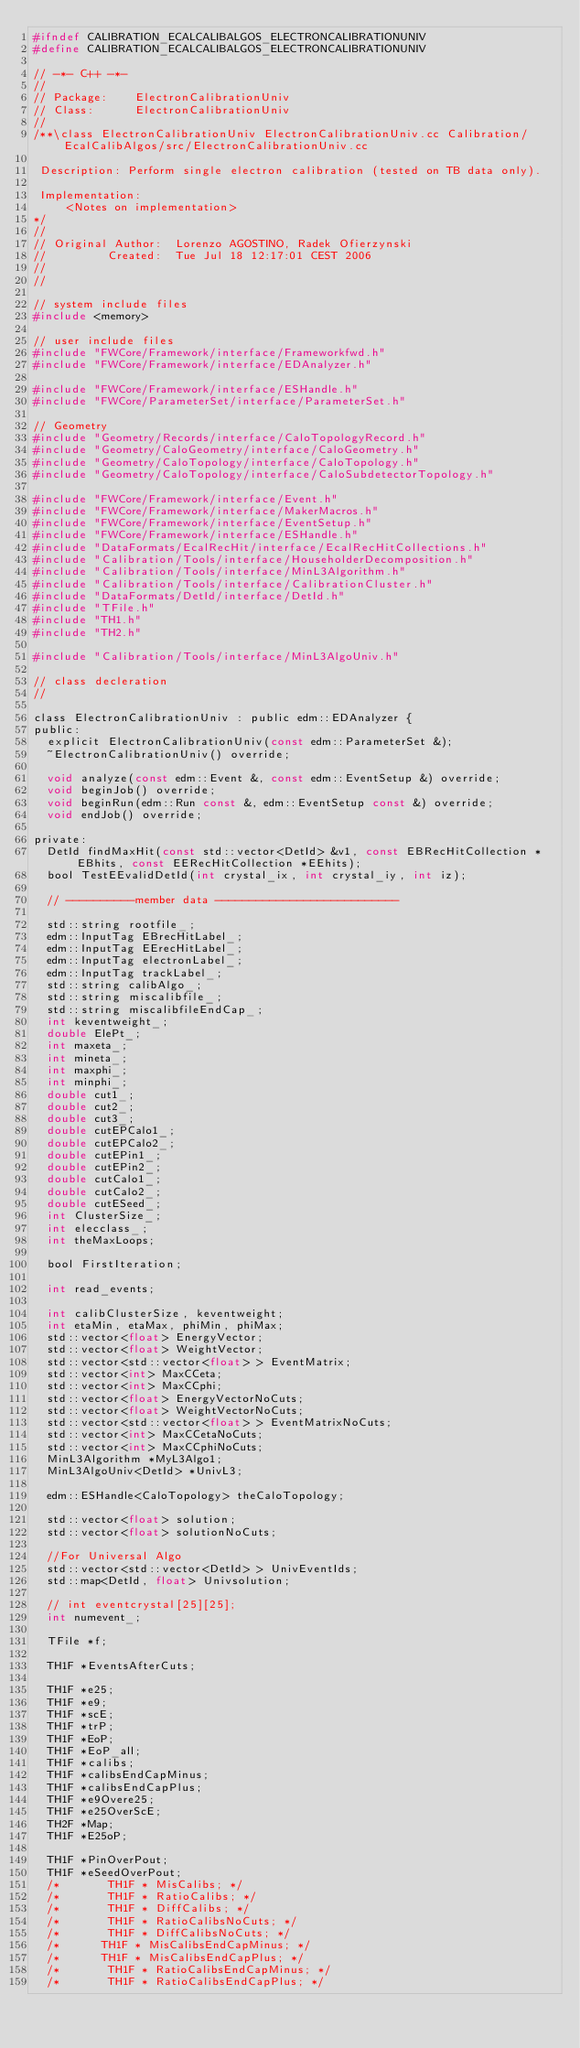Convert code to text. <code><loc_0><loc_0><loc_500><loc_500><_C_>#ifndef CALIBRATION_ECALCALIBALGOS_ELECTRONCALIBRATIONUNIV
#define CALIBRATION_ECALCALIBALGOS_ELECTRONCALIBRATIONUNIV

// -*- C++ -*-
//
// Package:    ElectronCalibrationUniv
// Class:      ElectronCalibrationUniv
//
/**\class ElectronCalibrationUniv ElectronCalibrationUniv.cc Calibration/EcalCalibAlgos/src/ElectronCalibrationUniv.cc

 Description: Perform single electron calibration (tested on TB data only).

 Implementation:
     <Notes on implementation>
*/
//
// Original Author:  Lorenzo AGOSTINO, Radek Ofierzynski
//         Created:  Tue Jul 18 12:17:01 CEST 2006
//
//

// system include files
#include <memory>

// user include files
#include "FWCore/Framework/interface/Frameworkfwd.h"
#include "FWCore/Framework/interface/EDAnalyzer.h"

#include "FWCore/Framework/interface/ESHandle.h"
#include "FWCore/ParameterSet/interface/ParameterSet.h"

// Geometry
#include "Geometry/Records/interface/CaloTopologyRecord.h"
#include "Geometry/CaloGeometry/interface/CaloGeometry.h"
#include "Geometry/CaloTopology/interface/CaloTopology.h"
#include "Geometry/CaloTopology/interface/CaloSubdetectorTopology.h"

#include "FWCore/Framework/interface/Event.h"
#include "FWCore/Framework/interface/MakerMacros.h"
#include "FWCore/Framework/interface/EventSetup.h"
#include "FWCore/Framework/interface/ESHandle.h"
#include "DataFormats/EcalRecHit/interface/EcalRecHitCollections.h"
#include "Calibration/Tools/interface/HouseholderDecomposition.h"
#include "Calibration/Tools/interface/MinL3Algorithm.h"
#include "Calibration/Tools/interface/CalibrationCluster.h"
#include "DataFormats/DetId/interface/DetId.h"
#include "TFile.h"
#include "TH1.h"
#include "TH2.h"

#include "Calibration/Tools/interface/MinL3AlgoUniv.h"

// class decleration
//

class ElectronCalibrationUniv : public edm::EDAnalyzer {
public:
  explicit ElectronCalibrationUniv(const edm::ParameterSet &);
  ~ElectronCalibrationUniv() override;

  void analyze(const edm::Event &, const edm::EventSetup &) override;
  void beginJob() override;
  void beginRun(edm::Run const &, edm::EventSetup const &) override;
  void endJob() override;

private:
  DetId findMaxHit(const std::vector<DetId> &v1, const EBRecHitCollection *EBhits, const EERecHitCollection *EEhits);
  bool TestEEvalidDetId(int crystal_ix, int crystal_iy, int iz);

  // ----------member data ---------------------------

  std::string rootfile_;
  edm::InputTag EBrecHitLabel_;
  edm::InputTag EErecHitLabel_;
  edm::InputTag electronLabel_;
  edm::InputTag trackLabel_;
  std::string calibAlgo_;
  std::string miscalibfile_;
  std::string miscalibfileEndCap_;
  int keventweight_;
  double ElePt_;
  int maxeta_;
  int mineta_;
  int maxphi_;
  int minphi_;
  double cut1_;
  double cut2_;
  double cut3_;
  double cutEPCalo1_;
  double cutEPCalo2_;
  double cutEPin1_;
  double cutEPin2_;
  double cutCalo1_;
  double cutCalo2_;
  double cutESeed_;
  int ClusterSize_;
  int elecclass_;
  int theMaxLoops;

  bool FirstIteration;

  int read_events;

  int calibClusterSize, keventweight;
  int etaMin, etaMax, phiMin, phiMax;
  std::vector<float> EnergyVector;
  std::vector<float> WeightVector;
  std::vector<std::vector<float> > EventMatrix;
  std::vector<int> MaxCCeta;
  std::vector<int> MaxCCphi;
  std::vector<float> EnergyVectorNoCuts;
  std::vector<float> WeightVectorNoCuts;
  std::vector<std::vector<float> > EventMatrixNoCuts;
  std::vector<int> MaxCCetaNoCuts;
  std::vector<int> MaxCCphiNoCuts;
  MinL3Algorithm *MyL3Algo1;
  MinL3AlgoUniv<DetId> *UnivL3;

  edm::ESHandle<CaloTopology> theCaloTopology;

  std::vector<float> solution;
  std::vector<float> solutionNoCuts;

  //For Universal Algo
  std::vector<std::vector<DetId> > UnivEventIds;
  std::map<DetId, float> Univsolution;

  // int eventcrystal[25][25];
  int numevent_;

  TFile *f;

  TH1F *EventsAfterCuts;

  TH1F *e25;
  TH1F *e9;
  TH1F *scE;
  TH1F *trP;
  TH1F *EoP;
  TH1F *EoP_all;
  TH1F *calibs;
  TH1F *calibsEndCapMinus;
  TH1F *calibsEndCapPlus;
  TH1F *e9Overe25;
  TH1F *e25OverScE;
  TH2F *Map;
  TH1F *E25oP;

  TH1F *PinOverPout;
  TH1F *eSeedOverPout;
  /*       TH1F * MisCalibs; */
  /*       TH1F * RatioCalibs; */
  /*       TH1F * DiffCalibs; */
  /*       TH1F * RatioCalibsNoCuts; */
  /*       TH1F * DiffCalibsNoCuts; */
  /*      TH1F * MisCalibsEndCapMinus; */
  /*      TH1F * MisCalibsEndCapPlus; */
  /*       TH1F * RatioCalibsEndCapMinus; */
  /*       TH1F * RatioCalibsEndCapPlus; */</code> 